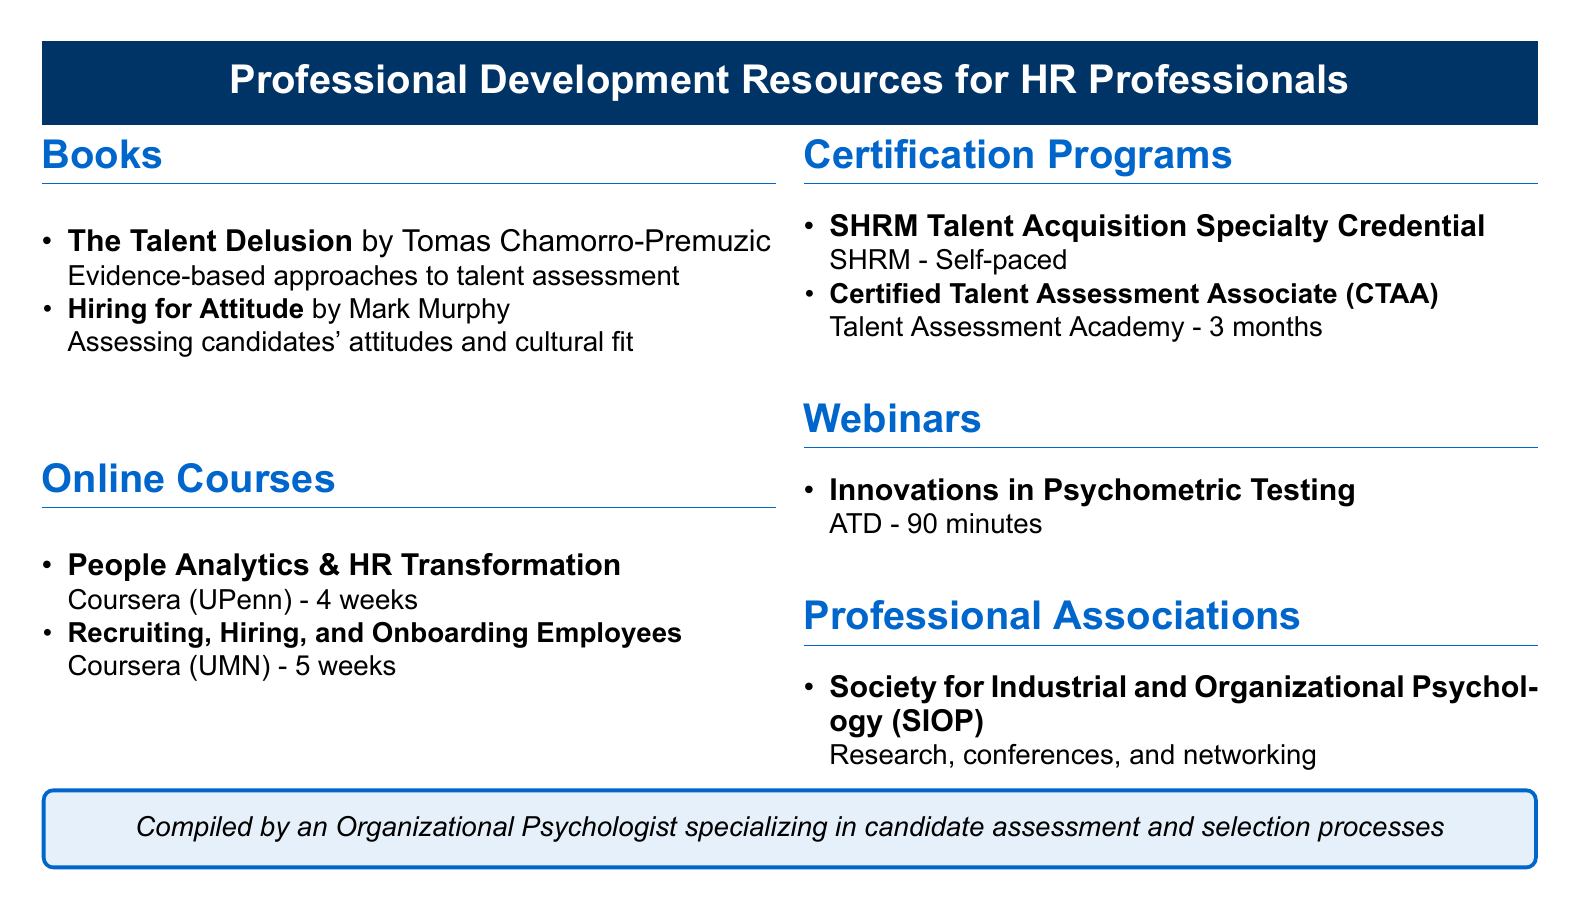What is the title of the book by Tomas Chamorro-Premuzic? The title of the book is found in the list of books, specifically attributed to Tomas Chamorro-Premuzic.
Answer: The Talent Delusion How long is the Coursera course "People Analytics & HR Transformation"? The duration of the course is mentioned in the online courses section of the document.
Answer: 4 weeks What type of credential does SHRM offer? This information is in the certification programs section, detailing what SHRM awards.
Answer: Talent Acquisition Specialty Credential Who is the author of "Hiring for Attitude"? The author is specified next to the book title in the list of books.
Answer: Mark Murphy What is the duration of the ATD webinar on psychometric testing? The duration is provided in the webinars section of the document.
Answer: 90 minutes Which organization provides the Certified Talent Assessment Associate program? The provider of this certification is outlined in the certification programs section.
Answer: Talent Assessment Academy What does SIOP stand for? This acronym is explained within the context of the professional associations section.
Answer: Society for Industrial and Organizational Psychology How many weeks is the "Recruiting, Hiring, and Onboarding Employees" course? The duration of the course can be found in the online courses section of the document.
Answer: 5 weeks 